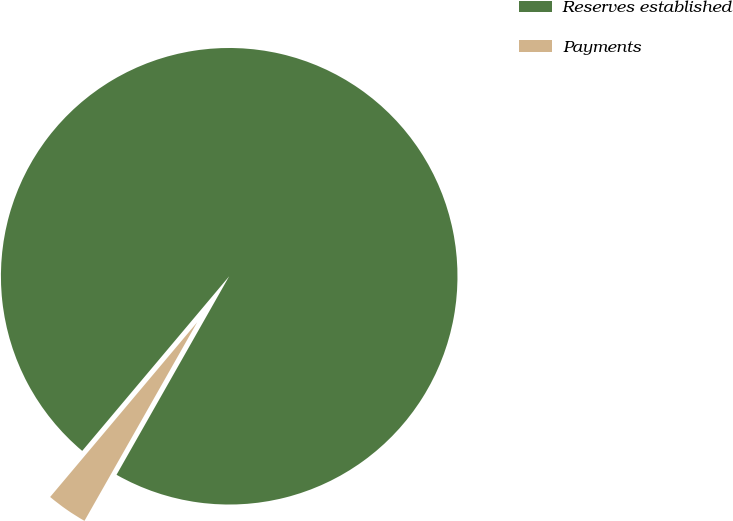Convert chart. <chart><loc_0><loc_0><loc_500><loc_500><pie_chart><fcel>Reserves established<fcel>Payments<nl><fcel>97.08%<fcel>2.92%<nl></chart> 